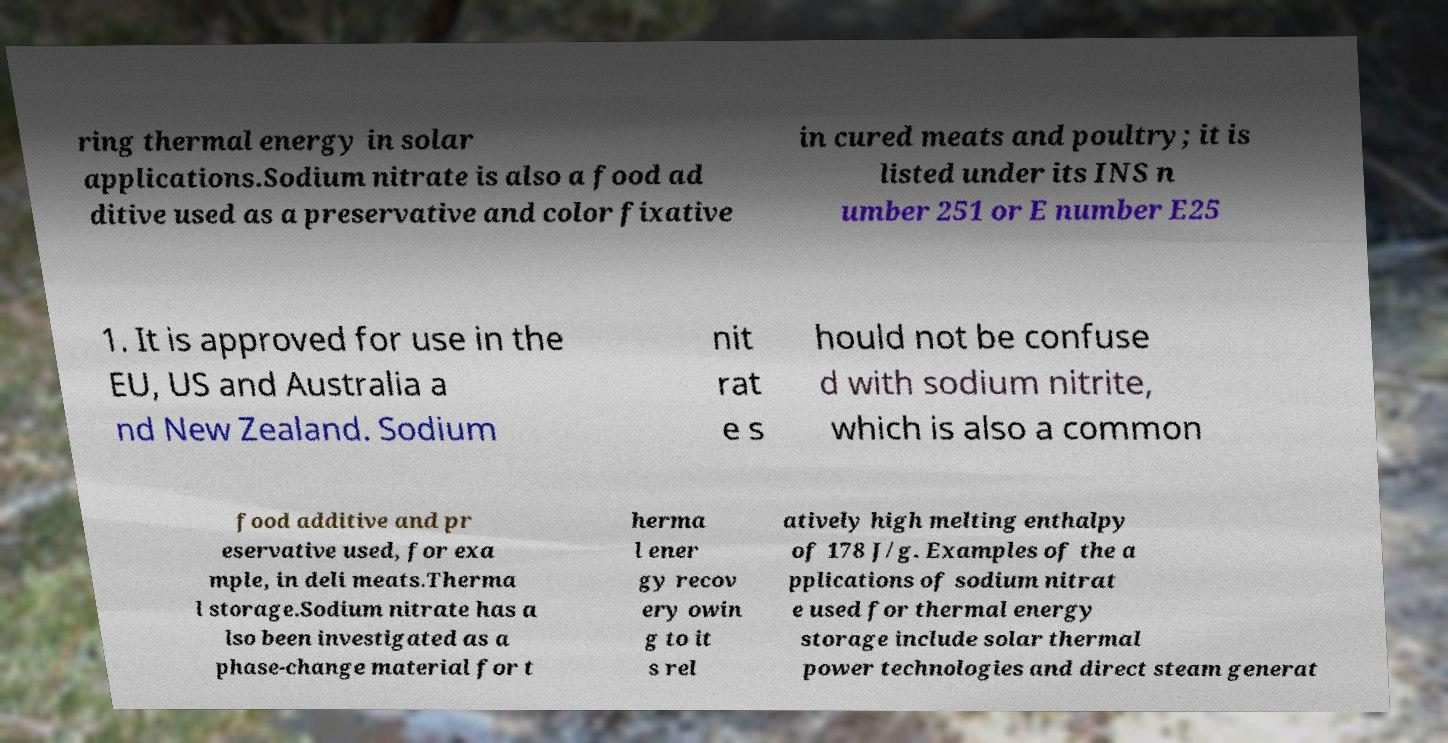I need the written content from this picture converted into text. Can you do that? ring thermal energy in solar applications.Sodium nitrate is also a food ad ditive used as a preservative and color fixative in cured meats and poultry; it is listed under its INS n umber 251 or E number E25 1. It is approved for use in the EU, US and Australia a nd New Zealand. Sodium nit rat e s hould not be confuse d with sodium nitrite, which is also a common food additive and pr eservative used, for exa mple, in deli meats.Therma l storage.Sodium nitrate has a lso been investigated as a phase-change material for t herma l ener gy recov ery owin g to it s rel atively high melting enthalpy of 178 J/g. Examples of the a pplications of sodium nitrat e used for thermal energy storage include solar thermal power technologies and direct steam generat 